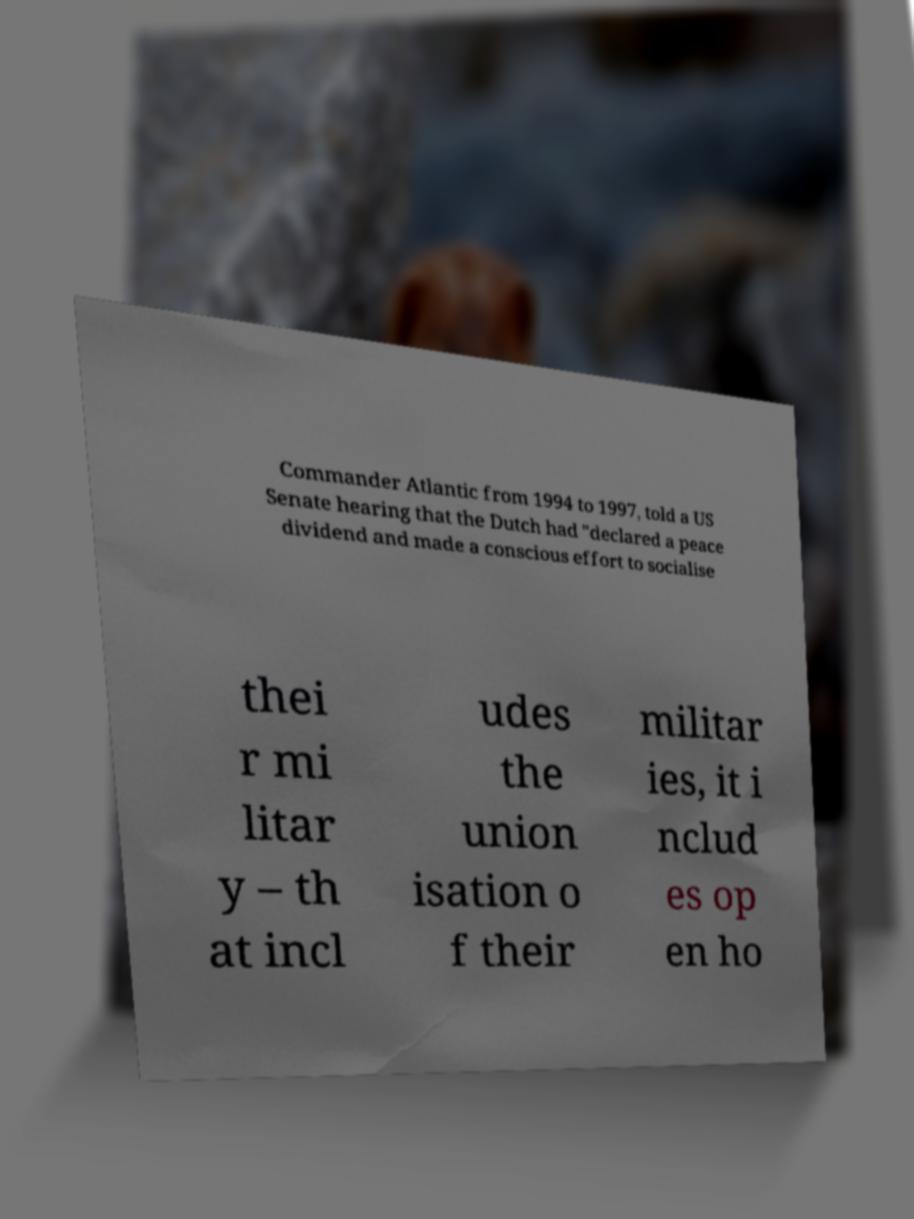What messages or text are displayed in this image? I need them in a readable, typed format. Commander Atlantic from 1994 to 1997, told a US Senate hearing that the Dutch had "declared a peace dividend and made a conscious effort to socialise thei r mi litar y – th at incl udes the union isation o f their militar ies, it i nclud es op en ho 